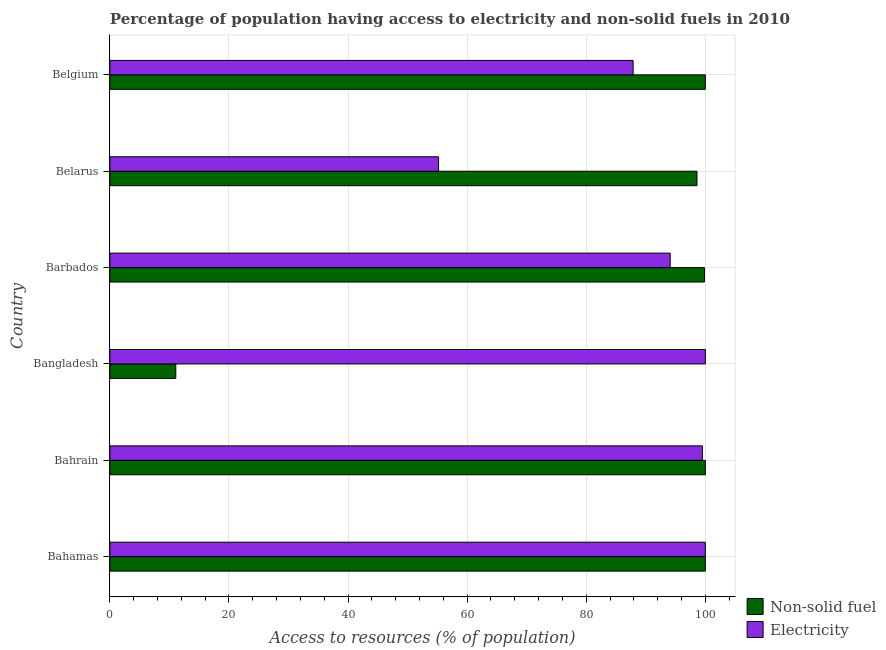Are the number of bars per tick equal to the number of legend labels?
Ensure brevity in your answer.  Yes. Are the number of bars on each tick of the Y-axis equal?
Your response must be concise. Yes. How many bars are there on the 4th tick from the top?
Your answer should be very brief. 2. How many bars are there on the 2nd tick from the bottom?
Offer a very short reply. 2. What is the label of the 4th group of bars from the top?
Your answer should be compact. Bangladesh. In how many cases, is the number of bars for a given country not equal to the number of legend labels?
Keep it short and to the point. 0. Across all countries, what is the minimum percentage of population having access to electricity?
Offer a terse response. 55.2. In which country was the percentage of population having access to electricity maximum?
Ensure brevity in your answer.  Bahamas. What is the total percentage of population having access to non-solid fuel in the graph?
Your answer should be compact. 509.51. What is the difference between the percentage of population having access to non-solid fuel in Bangladesh and that in Belarus?
Your answer should be compact. -87.53. What is the difference between the percentage of population having access to non-solid fuel in Barbados and the percentage of population having access to electricity in Belarus?
Provide a succinct answer. 44.65. What is the average percentage of population having access to electricity per country?
Your response must be concise. 89.45. What is the difference between the percentage of population having access to electricity and percentage of population having access to non-solid fuel in Belgium?
Provide a succinct answer. -12.13. In how many countries, is the percentage of population having access to non-solid fuel greater than 64 %?
Your answer should be very brief. 5. Is the percentage of population having access to electricity in Bangladesh less than that in Barbados?
Your answer should be compact. No. Is the difference between the percentage of population having access to electricity in Belarus and Belgium greater than the difference between the percentage of population having access to non-solid fuel in Belarus and Belgium?
Your answer should be compact. No. What is the difference between the highest and the second highest percentage of population having access to non-solid fuel?
Your answer should be very brief. 0. What is the difference between the highest and the lowest percentage of population having access to electricity?
Offer a very short reply. 44.8. Is the sum of the percentage of population having access to electricity in Bangladesh and Belarus greater than the maximum percentage of population having access to non-solid fuel across all countries?
Offer a very short reply. Yes. What does the 1st bar from the top in Belgium represents?
Your response must be concise. Electricity. What does the 2nd bar from the bottom in Bahamas represents?
Your answer should be compact. Electricity. Are all the bars in the graph horizontal?
Offer a very short reply. Yes. How many countries are there in the graph?
Your response must be concise. 6. Are the values on the major ticks of X-axis written in scientific E-notation?
Keep it short and to the point. No. Does the graph contain any zero values?
Ensure brevity in your answer.  No. Where does the legend appear in the graph?
Offer a terse response. Bottom right. How are the legend labels stacked?
Ensure brevity in your answer.  Vertical. What is the title of the graph?
Offer a very short reply. Percentage of population having access to electricity and non-solid fuels in 2010. Does "Passenger Transport Items" appear as one of the legend labels in the graph?
Your response must be concise. No. What is the label or title of the X-axis?
Give a very brief answer. Access to resources (% of population). What is the label or title of the Y-axis?
Offer a very short reply. Country. What is the Access to resources (% of population) of Non-solid fuel in Bahamas?
Offer a terse response. 100. What is the Access to resources (% of population) of Electricity in Bahamas?
Make the answer very short. 100. What is the Access to resources (% of population) in Electricity in Bahrain?
Give a very brief answer. 99.5. What is the Access to resources (% of population) of Non-solid fuel in Bangladesh?
Ensure brevity in your answer.  11.07. What is the Access to resources (% of population) of Non-solid fuel in Barbados?
Offer a terse response. 99.85. What is the Access to resources (% of population) in Electricity in Barbados?
Ensure brevity in your answer.  94.1. What is the Access to resources (% of population) of Non-solid fuel in Belarus?
Provide a short and direct response. 98.6. What is the Access to resources (% of population) in Electricity in Belarus?
Provide a short and direct response. 55.2. What is the Access to resources (% of population) in Non-solid fuel in Belgium?
Your answer should be very brief. 100. What is the Access to resources (% of population) in Electricity in Belgium?
Ensure brevity in your answer.  87.87. Across all countries, what is the minimum Access to resources (% of population) in Non-solid fuel?
Ensure brevity in your answer.  11.07. Across all countries, what is the minimum Access to resources (% of population) in Electricity?
Offer a very short reply. 55.2. What is the total Access to resources (% of population) of Non-solid fuel in the graph?
Your answer should be very brief. 509.51. What is the total Access to resources (% of population) in Electricity in the graph?
Ensure brevity in your answer.  536.67. What is the difference between the Access to resources (% of population) of Non-solid fuel in Bahamas and that in Bahrain?
Provide a short and direct response. 0. What is the difference between the Access to resources (% of population) in Electricity in Bahamas and that in Bahrain?
Ensure brevity in your answer.  0.5. What is the difference between the Access to resources (% of population) of Non-solid fuel in Bahamas and that in Bangladesh?
Provide a succinct answer. 88.93. What is the difference between the Access to resources (% of population) in Electricity in Bahamas and that in Bangladesh?
Offer a terse response. 0. What is the difference between the Access to resources (% of population) of Non-solid fuel in Bahamas and that in Barbados?
Ensure brevity in your answer.  0.15. What is the difference between the Access to resources (% of population) of Electricity in Bahamas and that in Barbados?
Your answer should be compact. 5.9. What is the difference between the Access to resources (% of population) in Non-solid fuel in Bahamas and that in Belarus?
Provide a short and direct response. 1.4. What is the difference between the Access to resources (% of population) in Electricity in Bahamas and that in Belarus?
Keep it short and to the point. 44.8. What is the difference between the Access to resources (% of population) of Non-solid fuel in Bahamas and that in Belgium?
Offer a terse response. 0. What is the difference between the Access to resources (% of population) in Electricity in Bahamas and that in Belgium?
Ensure brevity in your answer.  12.13. What is the difference between the Access to resources (% of population) in Non-solid fuel in Bahrain and that in Bangladesh?
Make the answer very short. 88.93. What is the difference between the Access to resources (% of population) of Non-solid fuel in Bahrain and that in Barbados?
Ensure brevity in your answer.  0.15. What is the difference between the Access to resources (% of population) in Electricity in Bahrain and that in Barbados?
Make the answer very short. 5.4. What is the difference between the Access to resources (% of population) in Non-solid fuel in Bahrain and that in Belarus?
Provide a succinct answer. 1.4. What is the difference between the Access to resources (% of population) in Electricity in Bahrain and that in Belarus?
Your response must be concise. 44.3. What is the difference between the Access to resources (% of population) of Electricity in Bahrain and that in Belgium?
Your answer should be very brief. 11.63. What is the difference between the Access to resources (% of population) in Non-solid fuel in Bangladesh and that in Barbados?
Provide a succinct answer. -88.78. What is the difference between the Access to resources (% of population) of Non-solid fuel in Bangladesh and that in Belarus?
Provide a succinct answer. -87.53. What is the difference between the Access to resources (% of population) in Electricity in Bangladesh and that in Belarus?
Offer a terse response. 44.8. What is the difference between the Access to resources (% of population) of Non-solid fuel in Bangladesh and that in Belgium?
Ensure brevity in your answer.  -88.93. What is the difference between the Access to resources (% of population) of Electricity in Bangladesh and that in Belgium?
Ensure brevity in your answer.  12.13. What is the difference between the Access to resources (% of population) in Non-solid fuel in Barbados and that in Belarus?
Provide a succinct answer. 1.25. What is the difference between the Access to resources (% of population) in Electricity in Barbados and that in Belarus?
Your answer should be very brief. 38.9. What is the difference between the Access to resources (% of population) of Non-solid fuel in Barbados and that in Belgium?
Your answer should be very brief. -0.15. What is the difference between the Access to resources (% of population) of Electricity in Barbados and that in Belgium?
Provide a succinct answer. 6.23. What is the difference between the Access to resources (% of population) of Non-solid fuel in Belarus and that in Belgium?
Your answer should be very brief. -1.4. What is the difference between the Access to resources (% of population) of Electricity in Belarus and that in Belgium?
Give a very brief answer. -32.67. What is the difference between the Access to resources (% of population) in Non-solid fuel in Bahamas and the Access to resources (% of population) in Electricity in Bahrain?
Give a very brief answer. 0.5. What is the difference between the Access to resources (% of population) in Non-solid fuel in Bahamas and the Access to resources (% of population) in Electricity in Bangladesh?
Your answer should be compact. 0. What is the difference between the Access to resources (% of population) of Non-solid fuel in Bahamas and the Access to resources (% of population) of Electricity in Belarus?
Provide a short and direct response. 44.8. What is the difference between the Access to resources (% of population) in Non-solid fuel in Bahamas and the Access to resources (% of population) in Electricity in Belgium?
Your answer should be compact. 12.13. What is the difference between the Access to resources (% of population) of Non-solid fuel in Bahrain and the Access to resources (% of population) of Electricity in Bangladesh?
Offer a very short reply. 0. What is the difference between the Access to resources (% of population) in Non-solid fuel in Bahrain and the Access to resources (% of population) in Electricity in Barbados?
Your response must be concise. 5.9. What is the difference between the Access to resources (% of population) of Non-solid fuel in Bahrain and the Access to resources (% of population) of Electricity in Belarus?
Provide a short and direct response. 44.8. What is the difference between the Access to resources (% of population) of Non-solid fuel in Bahrain and the Access to resources (% of population) of Electricity in Belgium?
Ensure brevity in your answer.  12.13. What is the difference between the Access to resources (% of population) in Non-solid fuel in Bangladesh and the Access to resources (% of population) in Electricity in Barbados?
Provide a short and direct response. -83.03. What is the difference between the Access to resources (% of population) of Non-solid fuel in Bangladesh and the Access to resources (% of population) of Electricity in Belarus?
Offer a terse response. -44.13. What is the difference between the Access to resources (% of population) of Non-solid fuel in Bangladesh and the Access to resources (% of population) of Electricity in Belgium?
Your answer should be very brief. -76.81. What is the difference between the Access to resources (% of population) in Non-solid fuel in Barbados and the Access to resources (% of population) in Electricity in Belarus?
Ensure brevity in your answer.  44.65. What is the difference between the Access to resources (% of population) of Non-solid fuel in Barbados and the Access to resources (% of population) of Electricity in Belgium?
Give a very brief answer. 11.97. What is the difference between the Access to resources (% of population) of Non-solid fuel in Belarus and the Access to resources (% of population) of Electricity in Belgium?
Keep it short and to the point. 10.73. What is the average Access to resources (% of population) of Non-solid fuel per country?
Ensure brevity in your answer.  84.92. What is the average Access to resources (% of population) in Electricity per country?
Your answer should be compact. 89.45. What is the difference between the Access to resources (% of population) in Non-solid fuel and Access to resources (% of population) in Electricity in Bahamas?
Ensure brevity in your answer.  0. What is the difference between the Access to resources (% of population) in Non-solid fuel and Access to resources (% of population) in Electricity in Bangladesh?
Ensure brevity in your answer.  -88.93. What is the difference between the Access to resources (% of population) of Non-solid fuel and Access to resources (% of population) of Electricity in Barbados?
Make the answer very short. 5.75. What is the difference between the Access to resources (% of population) of Non-solid fuel and Access to resources (% of population) of Electricity in Belarus?
Your answer should be compact. 43.4. What is the difference between the Access to resources (% of population) in Non-solid fuel and Access to resources (% of population) in Electricity in Belgium?
Ensure brevity in your answer.  12.13. What is the ratio of the Access to resources (% of population) of Non-solid fuel in Bahamas to that in Bahrain?
Make the answer very short. 1. What is the ratio of the Access to resources (% of population) of Non-solid fuel in Bahamas to that in Bangladesh?
Keep it short and to the point. 9.04. What is the ratio of the Access to resources (% of population) in Electricity in Bahamas to that in Bangladesh?
Provide a short and direct response. 1. What is the ratio of the Access to resources (% of population) of Non-solid fuel in Bahamas to that in Barbados?
Provide a succinct answer. 1. What is the ratio of the Access to resources (% of population) of Electricity in Bahamas to that in Barbados?
Offer a terse response. 1.06. What is the ratio of the Access to resources (% of population) of Non-solid fuel in Bahamas to that in Belarus?
Give a very brief answer. 1.01. What is the ratio of the Access to resources (% of population) of Electricity in Bahamas to that in Belarus?
Your response must be concise. 1.81. What is the ratio of the Access to resources (% of population) in Electricity in Bahamas to that in Belgium?
Offer a terse response. 1.14. What is the ratio of the Access to resources (% of population) in Non-solid fuel in Bahrain to that in Bangladesh?
Make the answer very short. 9.04. What is the ratio of the Access to resources (% of population) of Non-solid fuel in Bahrain to that in Barbados?
Provide a short and direct response. 1. What is the ratio of the Access to resources (% of population) in Electricity in Bahrain to that in Barbados?
Provide a short and direct response. 1.06. What is the ratio of the Access to resources (% of population) in Non-solid fuel in Bahrain to that in Belarus?
Your response must be concise. 1.01. What is the ratio of the Access to resources (% of population) in Electricity in Bahrain to that in Belarus?
Offer a terse response. 1.8. What is the ratio of the Access to resources (% of population) in Non-solid fuel in Bahrain to that in Belgium?
Your answer should be compact. 1. What is the ratio of the Access to resources (% of population) in Electricity in Bahrain to that in Belgium?
Provide a succinct answer. 1.13. What is the ratio of the Access to resources (% of population) of Non-solid fuel in Bangladesh to that in Barbados?
Your response must be concise. 0.11. What is the ratio of the Access to resources (% of population) in Electricity in Bangladesh to that in Barbados?
Provide a short and direct response. 1.06. What is the ratio of the Access to resources (% of population) of Non-solid fuel in Bangladesh to that in Belarus?
Offer a terse response. 0.11. What is the ratio of the Access to resources (% of population) of Electricity in Bangladesh to that in Belarus?
Provide a succinct answer. 1.81. What is the ratio of the Access to resources (% of population) of Non-solid fuel in Bangladesh to that in Belgium?
Offer a very short reply. 0.11. What is the ratio of the Access to resources (% of population) in Electricity in Bangladesh to that in Belgium?
Offer a terse response. 1.14. What is the ratio of the Access to resources (% of population) in Non-solid fuel in Barbados to that in Belarus?
Provide a short and direct response. 1.01. What is the ratio of the Access to resources (% of population) in Electricity in Barbados to that in Belarus?
Give a very brief answer. 1.7. What is the ratio of the Access to resources (% of population) in Non-solid fuel in Barbados to that in Belgium?
Keep it short and to the point. 1. What is the ratio of the Access to resources (% of population) in Electricity in Barbados to that in Belgium?
Offer a very short reply. 1.07. What is the ratio of the Access to resources (% of population) of Electricity in Belarus to that in Belgium?
Ensure brevity in your answer.  0.63. What is the difference between the highest and the second highest Access to resources (% of population) in Non-solid fuel?
Your answer should be compact. 0. What is the difference between the highest and the lowest Access to resources (% of population) of Non-solid fuel?
Provide a short and direct response. 88.93. What is the difference between the highest and the lowest Access to resources (% of population) of Electricity?
Offer a very short reply. 44.8. 